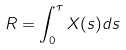Convert formula to latex. <formula><loc_0><loc_0><loc_500><loc_500>R = \int _ { 0 } ^ { \tau } X ( s ) d s</formula> 